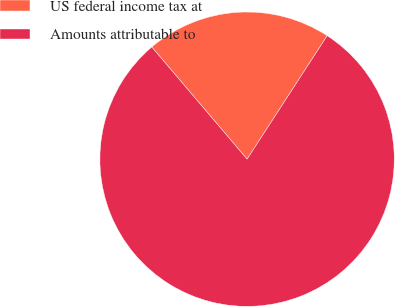Convert chart. <chart><loc_0><loc_0><loc_500><loc_500><pie_chart><fcel>US federal income tax at<fcel>Amounts attributable to<nl><fcel>20.37%<fcel>79.63%<nl></chart> 